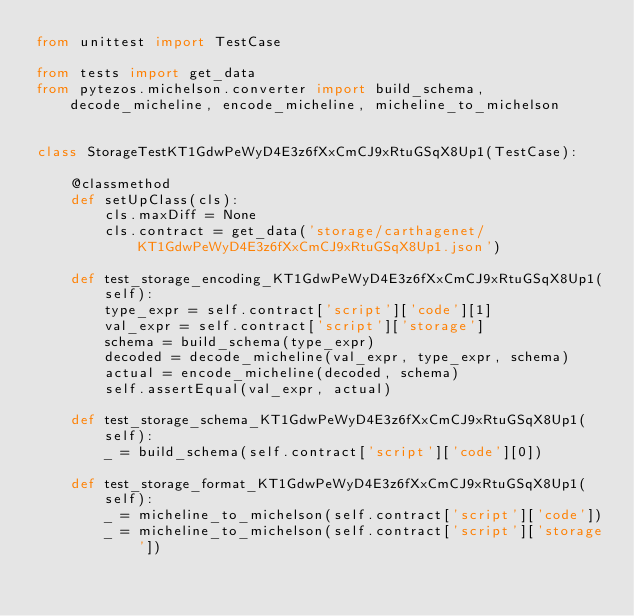Convert code to text. <code><loc_0><loc_0><loc_500><loc_500><_Python_>from unittest import TestCase

from tests import get_data
from pytezos.michelson.converter import build_schema, decode_micheline, encode_micheline, micheline_to_michelson


class StorageTestKT1GdwPeWyD4E3z6fXxCmCJ9xRtuGSqX8Up1(TestCase):

    @classmethod
    def setUpClass(cls):
        cls.maxDiff = None
        cls.contract = get_data('storage/carthagenet/KT1GdwPeWyD4E3z6fXxCmCJ9xRtuGSqX8Up1.json')

    def test_storage_encoding_KT1GdwPeWyD4E3z6fXxCmCJ9xRtuGSqX8Up1(self):
        type_expr = self.contract['script']['code'][1]
        val_expr = self.contract['script']['storage']
        schema = build_schema(type_expr)
        decoded = decode_micheline(val_expr, type_expr, schema)
        actual = encode_micheline(decoded, schema)
        self.assertEqual(val_expr, actual)

    def test_storage_schema_KT1GdwPeWyD4E3z6fXxCmCJ9xRtuGSqX8Up1(self):
        _ = build_schema(self.contract['script']['code'][0])

    def test_storage_format_KT1GdwPeWyD4E3z6fXxCmCJ9xRtuGSqX8Up1(self):
        _ = micheline_to_michelson(self.contract['script']['code'])
        _ = micheline_to_michelson(self.contract['script']['storage'])
</code> 